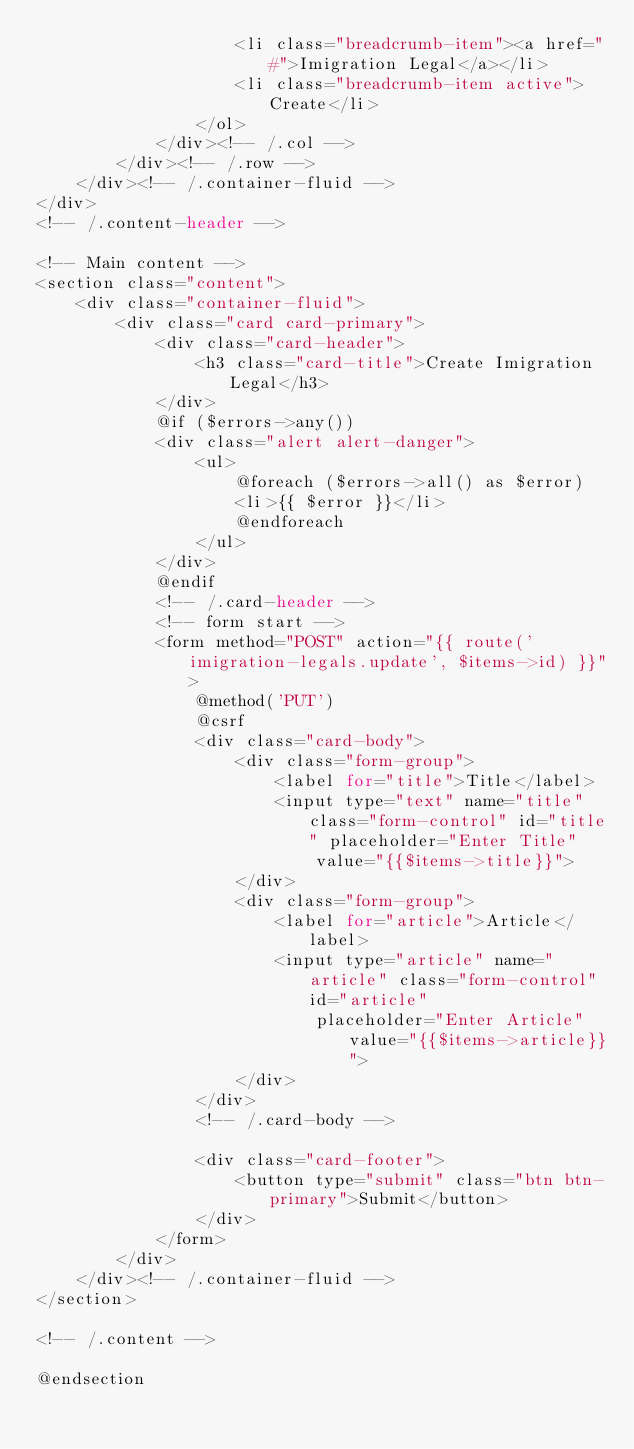<code> <loc_0><loc_0><loc_500><loc_500><_PHP_>                    <li class="breadcrumb-item"><a href="#">Imigration Legal</a></li>
                    <li class="breadcrumb-item active">Create</li>
                </ol>
            </div><!-- /.col -->
        </div><!-- /.row -->
    </div><!-- /.container-fluid -->
</div>
<!-- /.content-header -->

<!-- Main content -->
<section class="content">
    <div class="container-fluid">
        <div class="card card-primary">
            <div class="card-header">
                <h3 class="card-title">Create Imigration Legal</h3>
            </div>
            @if ($errors->any())
            <div class="alert alert-danger">
                <ul>
                    @foreach ($errors->all() as $error)
                    <li>{{ $error }}</li>
                    @endforeach
                </ul>
            </div>
            @endif
            <!-- /.card-header -->
            <!-- form start -->
            <form method="POST" action="{{ route('imigration-legals.update', $items->id) }}">
                @method('PUT')
                @csrf
                <div class="card-body">
                    <div class="form-group">
                        <label for="title">Title</label>
                        <input type="text" name="title" class="form-control" id="title" placeholder="Enter Title"
                            value="{{$items->title}}">
                    </div>
                    <div class="form-group">
                        <label for="article">Article</label>
                        <input type="article" name="article" class="form-control" id="article"
                            placeholder="Enter Article" value="{{$items->article}}">
                    </div>
                </div>
                <!-- /.card-body -->

                <div class="card-footer">
                    <button type="submit" class="btn btn-primary">Submit</button>
                </div>
            </form>
        </div>
    </div><!-- /.container-fluid -->
</section>

<!-- /.content -->

@endsection
</code> 